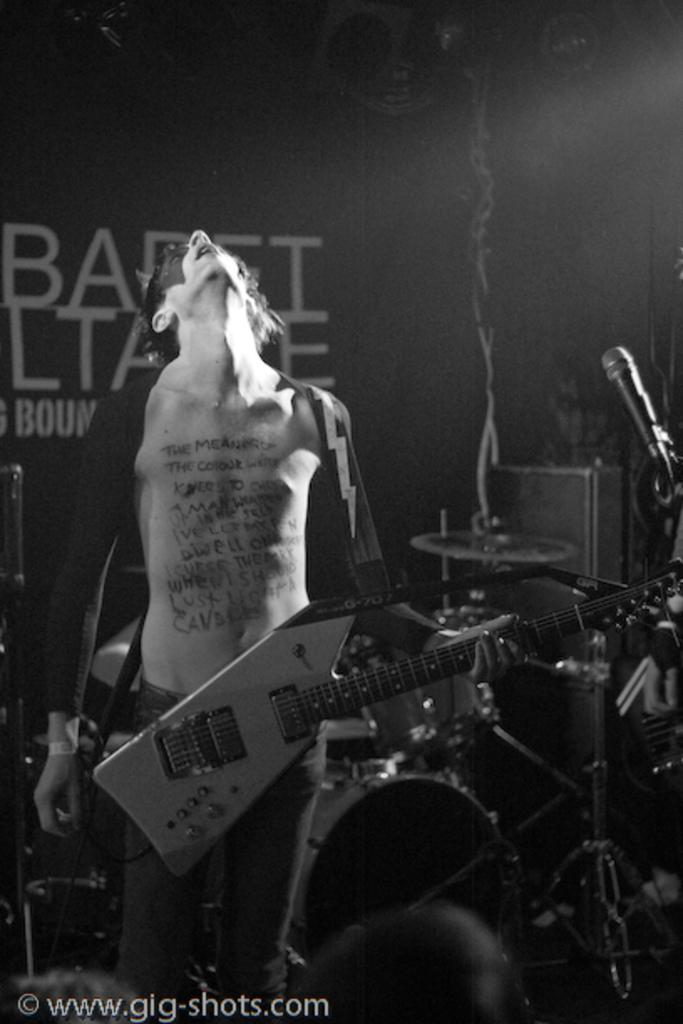Who is present in the image? There is a man in the image. What is the man holding in the image? The man is holding a guitar. What else can be seen in the image besides the man and the guitar? There are musical instruments and a banner in the image. What type of bomb is depicted on the banner in the image? There is no bomb present on the banner in the image; it is not mentioned in the provided facts. 